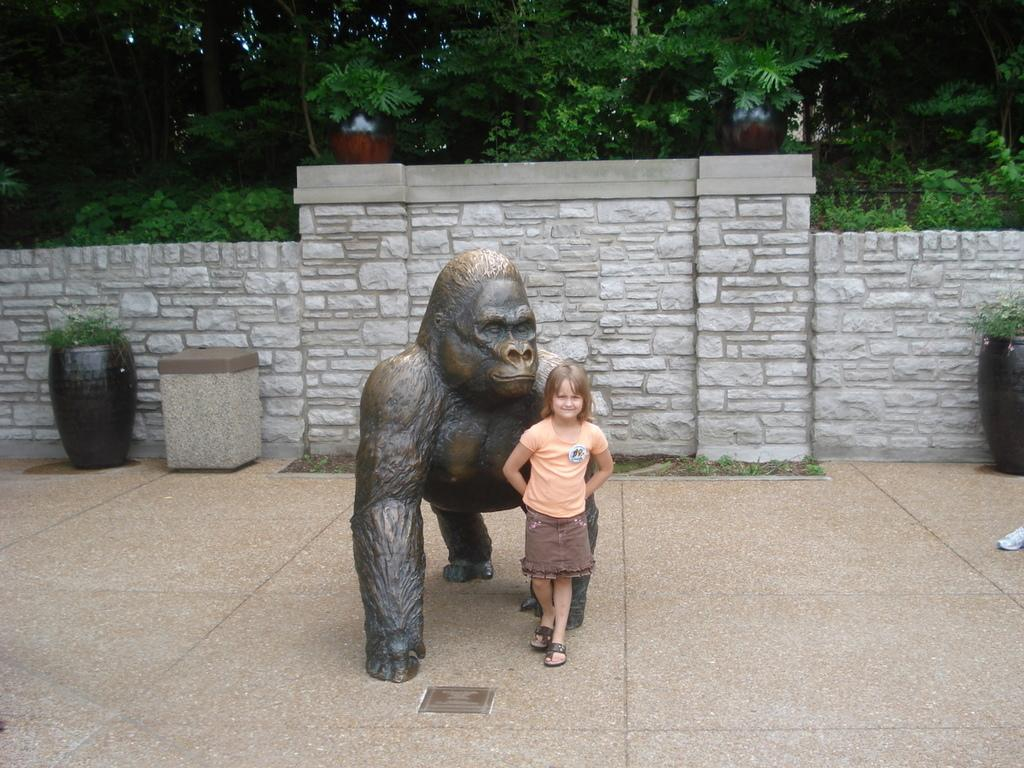Who is the main subject in the image? There is a girl standing in the center of the image. What can be seen besides the girl in the image? There is a sculpture in the image. What is visible in the background of the image? There is a wall, plants, and trees in the background of the image. How many cats are needed to complete the plot of the image? There are no cats present in the image, and therefore no plot involving cats can be determined. 